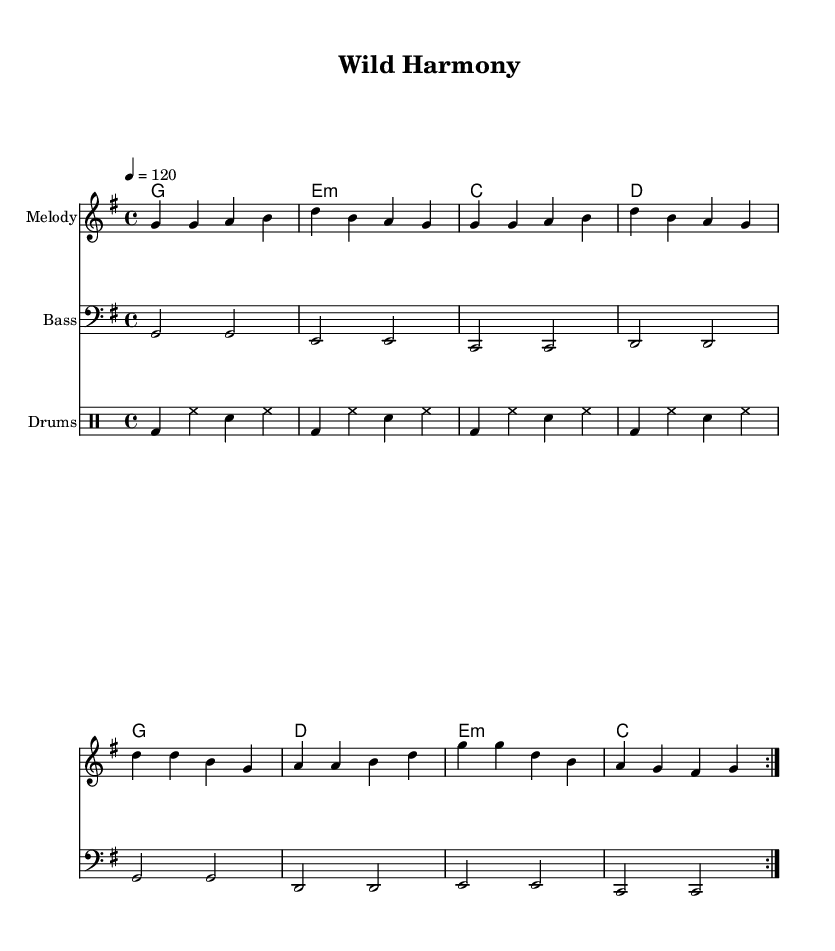What is the time signature of this music? The time signature is indicated at the beginning of the piece, shown as "4/4". This means there are four beats in each measure, with the quarter note getting one beat.
Answer: 4/4 What is the key signature of this music? The key signature is G major, which has one sharp (F#). This is evident from the key signature marking placed at the beginning of the staff before any notes.
Answer: G major What is the tempo marking of the piece? The tempo marking is given as "4 = 120", which signifies that the metronome should tick at 120 beats per minute. This is a common way to express the speed of a piece of music.
Answer: 120 How many measures are repeated in this composition? The repeat signs (volta) indicate that the section will be played twice, evident from the notation at the start and end of the repeated section. Since it explicitly states "repeat volta 2", it confirms a two-measure repetition.
Answer: 2 What type of accompaniment is used in this Rhythm and Blues composition? The accompaniment features chords which are common in Rhythm and Blues, along with a bass line and rhythmic drumming which typical in the genre, supporting the melody throughout the piece. The structure showcases the typical format of chords accompanying the melody.
Answer: Chords What are the first two notes of the melody? The first two notes of the melody, as seen in the upper staff where melody is written, are "G" and "G". This is the starting point of the musical phrase for the audience to grasp the thematic material.
Answer: G G What instruments are featured in this score? The score clearly features three parts named: "Melody", "Bass", and "Drums". Each part is designated an instrument name, indicating the use of melodic, harmonic, and rhythmic playing techniques common in Rhythm and Blues music.
Answer: Melody, Bass, Drums 